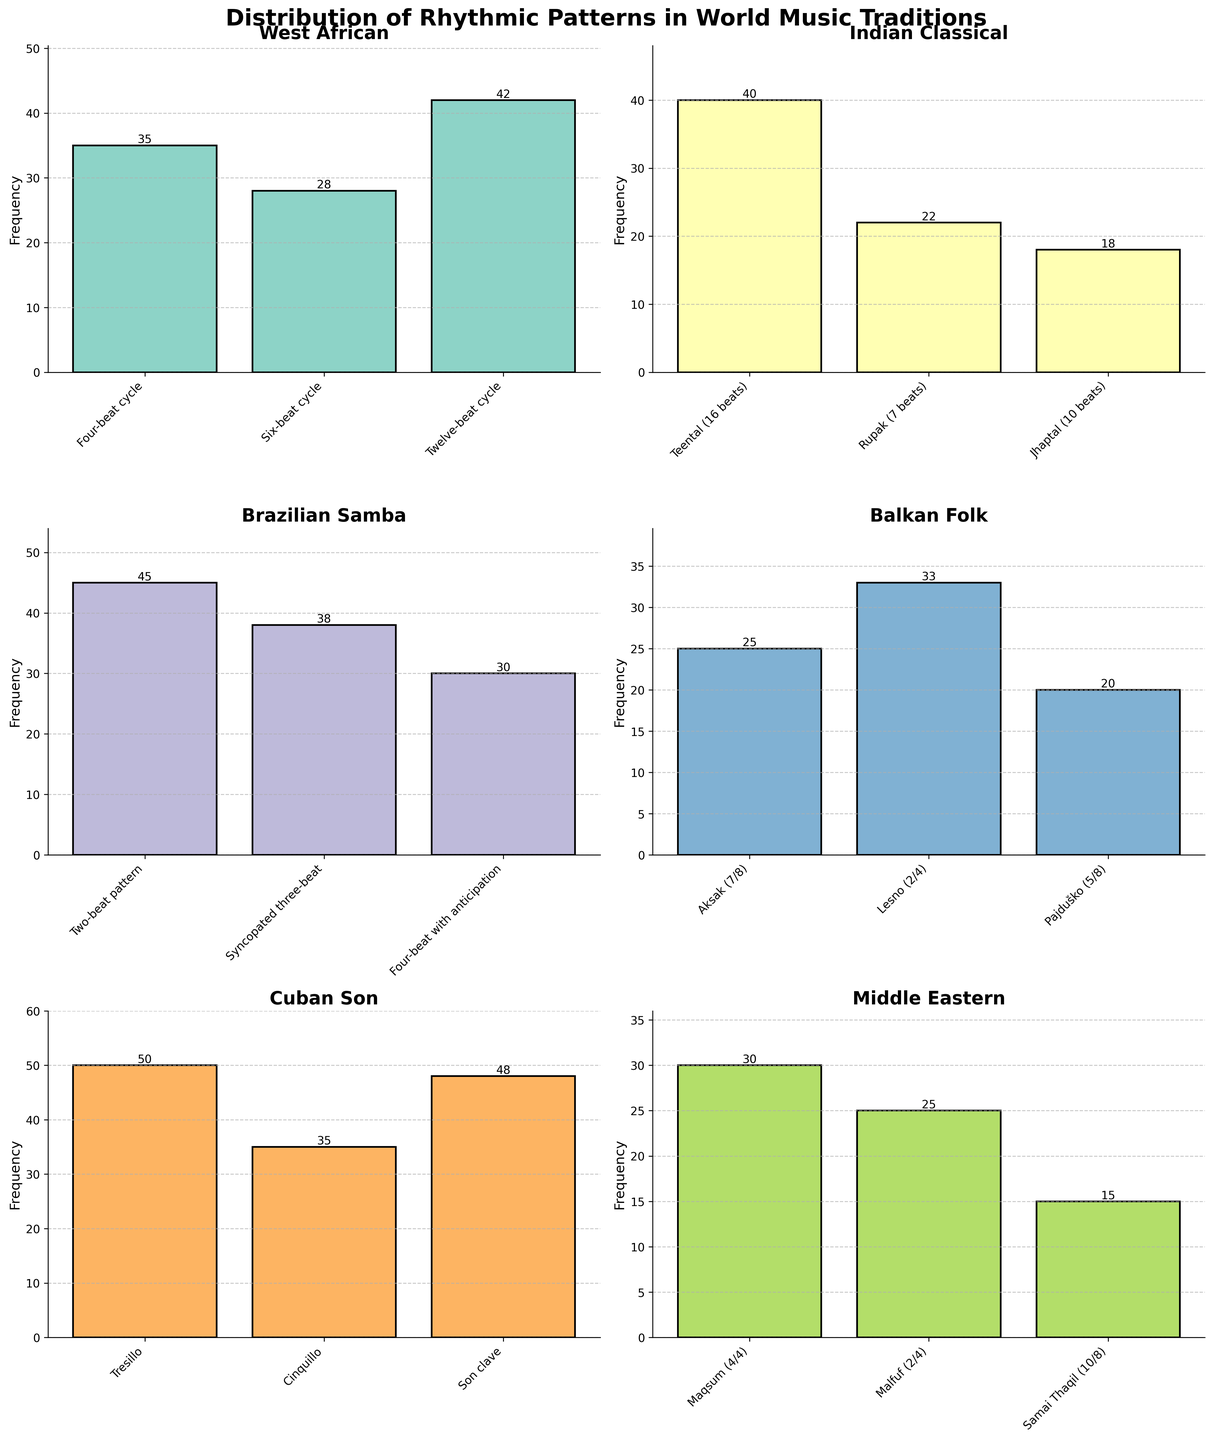What's the most common rhythmic pattern in Cuban Son music? To find the most common pattern, look at the bar with the highest frequency in the Cuban Son subplot. The Tresillo pattern has the highest bar.
Answer: Tresillo Which music tradition has the highest frequency for any rhythmic pattern? Compare the highest bar in each subplot. The Cuban Son subplot has the highest bar for Tresillo with a frequency of 50.
Answer: Cuban Son What's the frequency difference between the Syncopated three-beat and Four-beat with anticipation patterns in Brazilian Samba? Subtract the frequency of the Four-beat with anticipation pattern (30) from the frequency of the Syncopated three-beat pattern (38). 38-30=8
Answer: 8 Which rhythmic pattern is more common in West African music, Six-beat cycle or Four-beat cycle? Compare the frequencies of Six-beat cycle (28) and Four-beat cycle (35) in the West African subplot. The Four-beat cycle has a higher frequency.
Answer: Four-beat cycle How many rhythmic patterns are displayed in the Indian Classical subplot? Count the number of bars in the Indian Classical subplot. There are three bars: Teental, Rupak, and Jhaptal.
Answer: 3 What is the sum of the frequencies of all rhythmic patterns in the Middle Eastern subplot? Add the frequencies of all the bars in the Middle Eastern subplot: Maqsum (30) + Malfuf (25) + Samai Thaqil (15). 30+25+15=70
Answer: 70 Which rhythmic pattern in the Balkan Folk subplot has the smallest frequency? Look for the shortest bar in the Balkan Folk subplot. The Pajduško pattern has the smallest frequency with 20.
Answer: Pajduško What is the average frequency of the rhythmic patterns in the West African subplot? Sum the frequencies of all patterns in the West African subplot and divide by the number of patterns. (35+28+42)/3 = 105/3
Answer: 35 